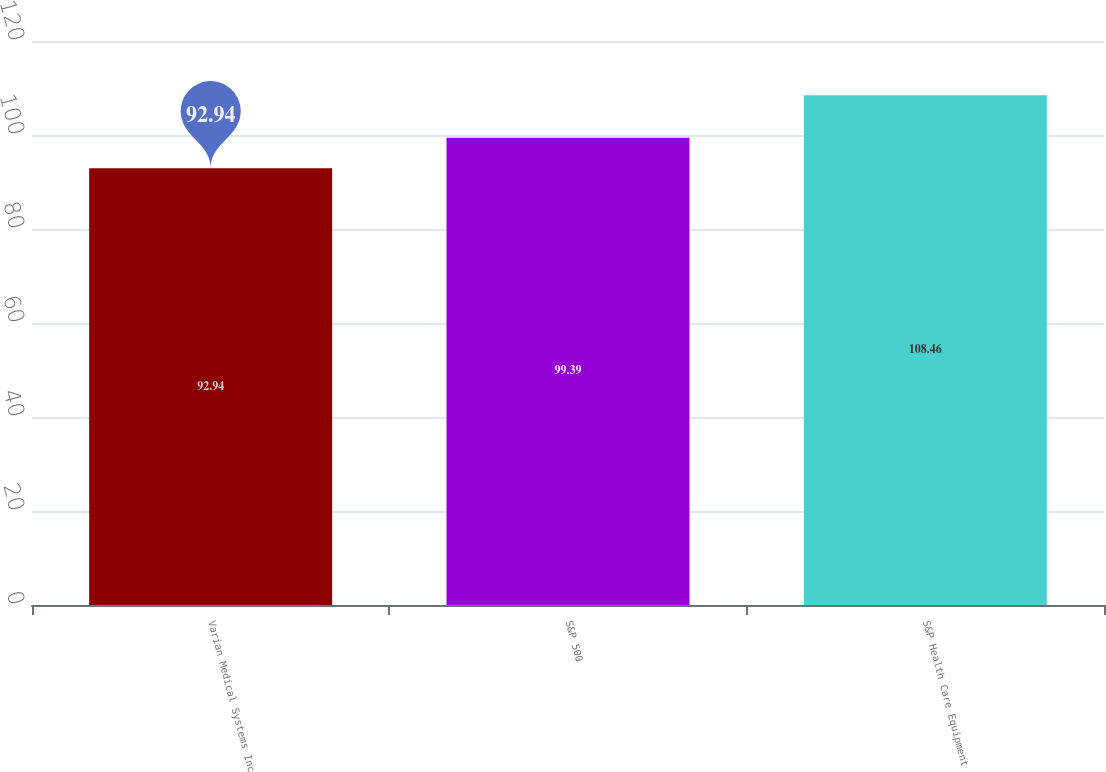Convert chart to OTSL. <chart><loc_0><loc_0><loc_500><loc_500><bar_chart><fcel>Varian Medical Systems Inc<fcel>S&P 500<fcel>S&P Health Care Equipment<nl><fcel>92.94<fcel>99.39<fcel>108.46<nl></chart> 